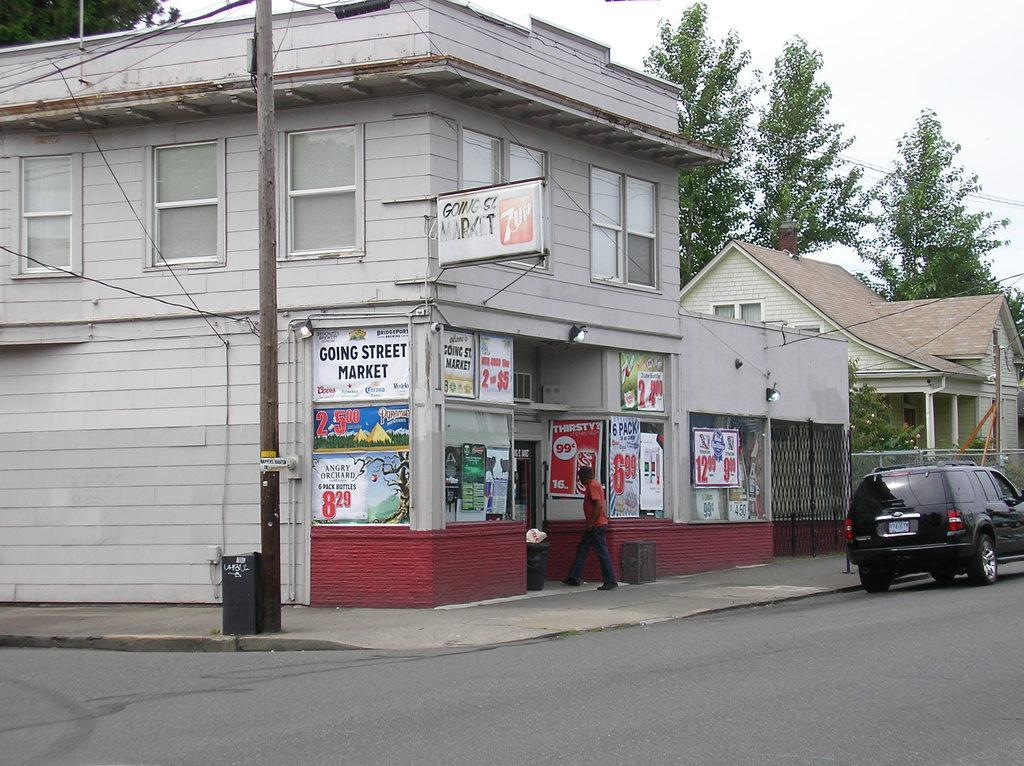What type of structures can be seen in the image? There are buildings in the image. What is the purpose of the pole in the image? There is a current pole in the image, which is used for providing electricity. What decorative elements are present in the image? There are banners in the image. Can you describe the person in the image? There is a man standing in the image. What mode of transportation is visible in the image? There is a car in the image. What type of vegetation is present in the image? There are trees in the image. What is visible at the top of the image? The sky is visible at the top of the image. What type of copper is being used to make the trees in the image? There is no copper present in the image, and the trees are not made of copper; they are natural vegetation. 